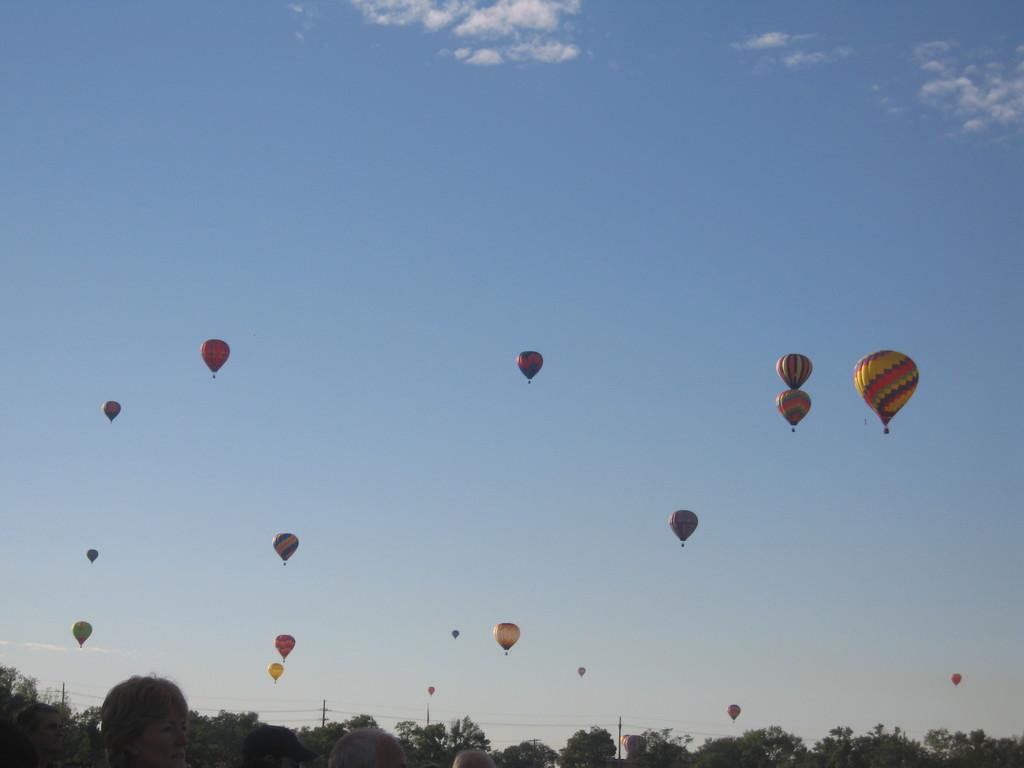How many people are in the image? There is a group of people in the image, but the exact number cannot be determined from the provided facts. What type of natural elements can be seen in the image? There are trees in the image. What man-made structures are present in the image? There are poles and wires in the image. What is happening in the sky in the image? There is a group of parachutes flying in the sky. Where is the jewel located in the image? There is no mention of a jewel in the image, so it cannot be located. What type of geese can be seen in the image? There is no mention of geese in the image, so they cannot be described. 